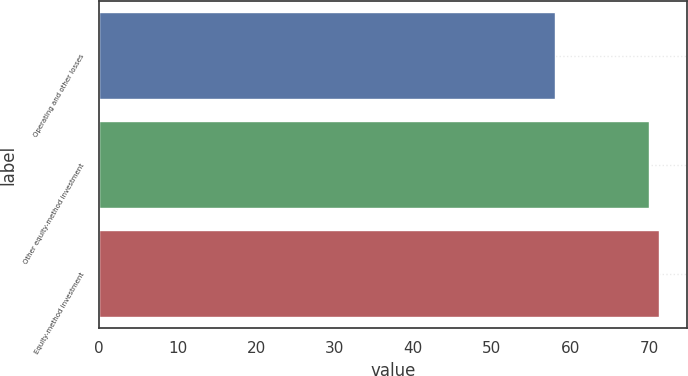Convert chart. <chart><loc_0><loc_0><loc_500><loc_500><bar_chart><fcel>Operating and other losses<fcel>Other equity-method investment<fcel>Equity-method investment<nl><fcel>58<fcel>70<fcel>71.3<nl></chart> 